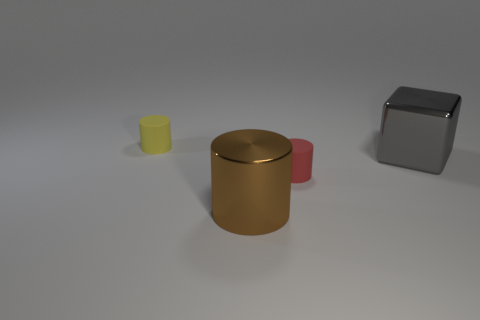Subtract all red rubber cylinders. How many cylinders are left? 2 Add 1 brown shiny balls. How many objects exist? 5 Subtract 1 cylinders. How many cylinders are left? 2 Subtract all cylinders. How many objects are left? 1 Add 4 brown metal cylinders. How many brown metal cylinders are left? 5 Add 4 large metallic things. How many large metallic things exist? 6 Subtract 0 blue balls. How many objects are left? 4 Subtract all green cylinders. Subtract all purple cubes. How many cylinders are left? 3 Subtract all tiny red objects. Subtract all yellow cylinders. How many objects are left? 2 